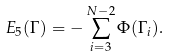Convert formula to latex. <formula><loc_0><loc_0><loc_500><loc_500>E _ { 5 } ( \Gamma ) = - \sum _ { i = 3 } ^ { N - 2 } \Phi ( \Gamma _ { i } ) .</formula> 